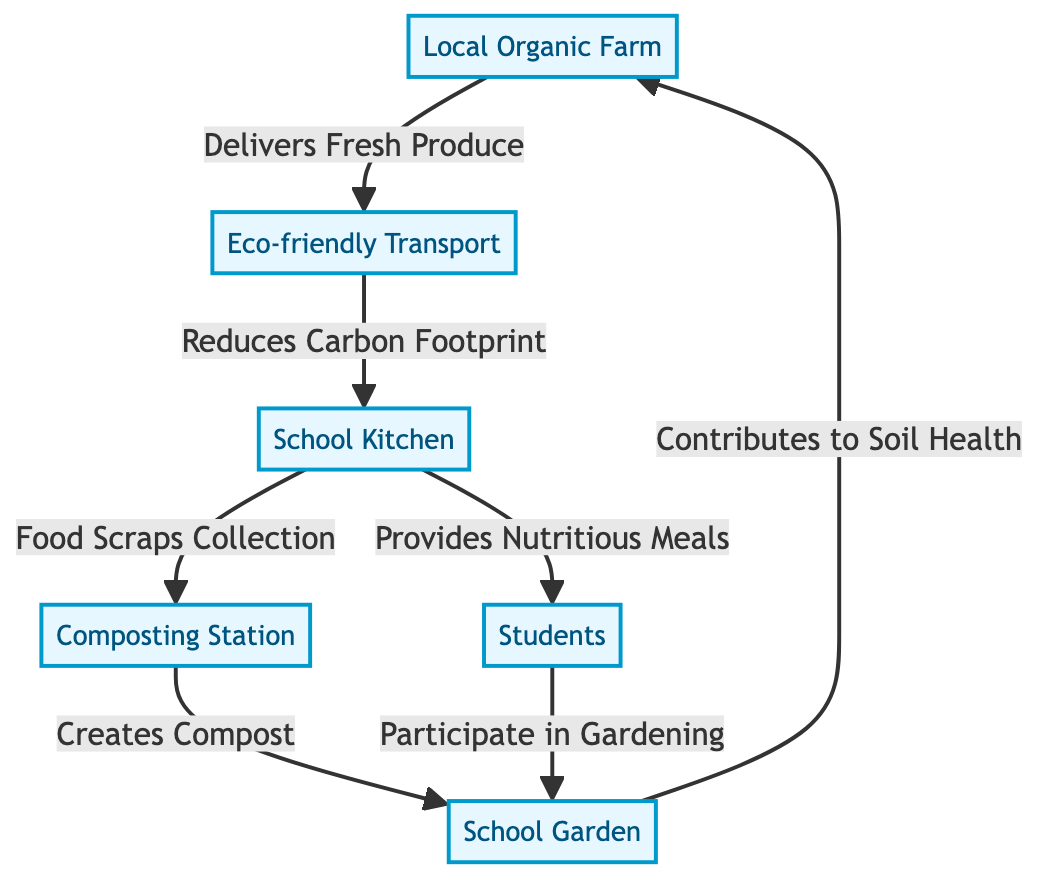What is the first node in the food chain? The first node in the food chain is labeled "Local Organic Farm." This can be identified as it is the starting point of the flowchart and has no inbound arrows.
Answer: Local Organic Farm How many nodes are present in the diagram? By counting each unique labeled component in the diagram, we find there are six nodes: Local Organic Farm, Eco-friendly Transport, School Kitchen, Composting Station, School Garden, and Students.
Answer: 6 What action does "Transport" perform in the food chain? The "Transport" node connects to the "School Kitchen" node with the action "Reduces Carbon Footprint," indicating its role in lowering emissions during food delivery.
Answer: Reduces Carbon Footprint What does "Composting Station" create? The flow from "Composting Station" leads to "School Garden" and is described with the action "Creates Compost," answering what is produced by that node.
Answer: Compost Which node directly connects to both the "School Kitchen" and "Garden"? The node "Composting Station" connects to the "School Kitchen" through food scraps collection and to the "Garden" through compost creation. This dual connection makes it central to both food waste management and soil health.
Answer: Composting Station What do students participate in according to the diagram? The "Students" node points to "Garden" with the action "Participate in Gardening," indicating the involvement of students in gardening activities.
Answer: Gardening What is the relationship between the "School Garden" and "Local Organic Farm"? The "School Garden" contributes to "Soil Health," which then cyclically links back to the "Local Organic Farm," suggesting an ecological loop benefiting both entities in sustainability practices.
Answer: Contributes to Soil Health What is the primary output of the "School Kitchen"? The main output of the "School Kitchen" is described as "Provides Nutritious Meals" to the "Students," indicating that its primary role is meal preparation.
Answer: Provides Nutritious Meals How do food scraps from "School Kitchen" impact the "Composting Station"? The flowchart indicates a direct action from the "School Kitchen" to the "Composting Station" labeled "Food Scraps Collection," demonstrating how food waste is managed and utilized for composting.
Answer: Food Scraps Collection 